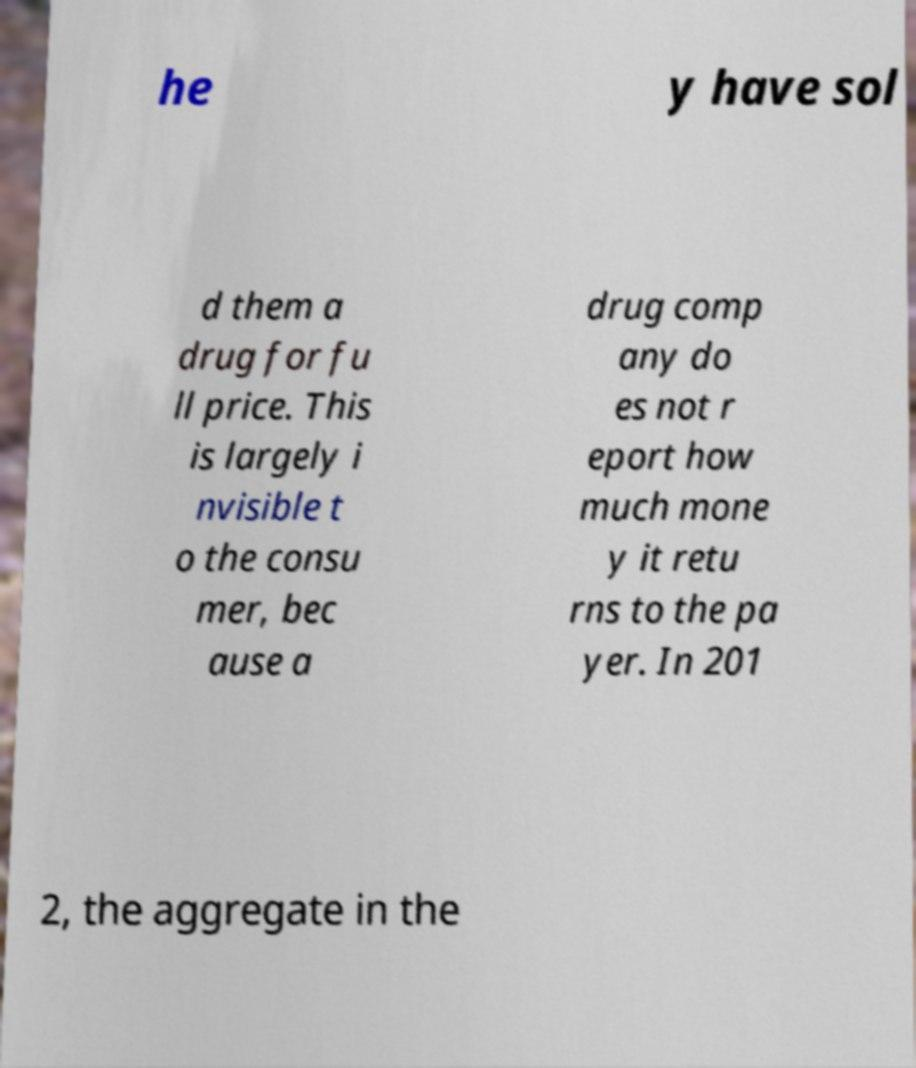Please read and relay the text visible in this image. What does it say? he y have sol d them a drug for fu ll price. This is largely i nvisible t o the consu mer, bec ause a drug comp any do es not r eport how much mone y it retu rns to the pa yer. In 201 2, the aggregate in the 